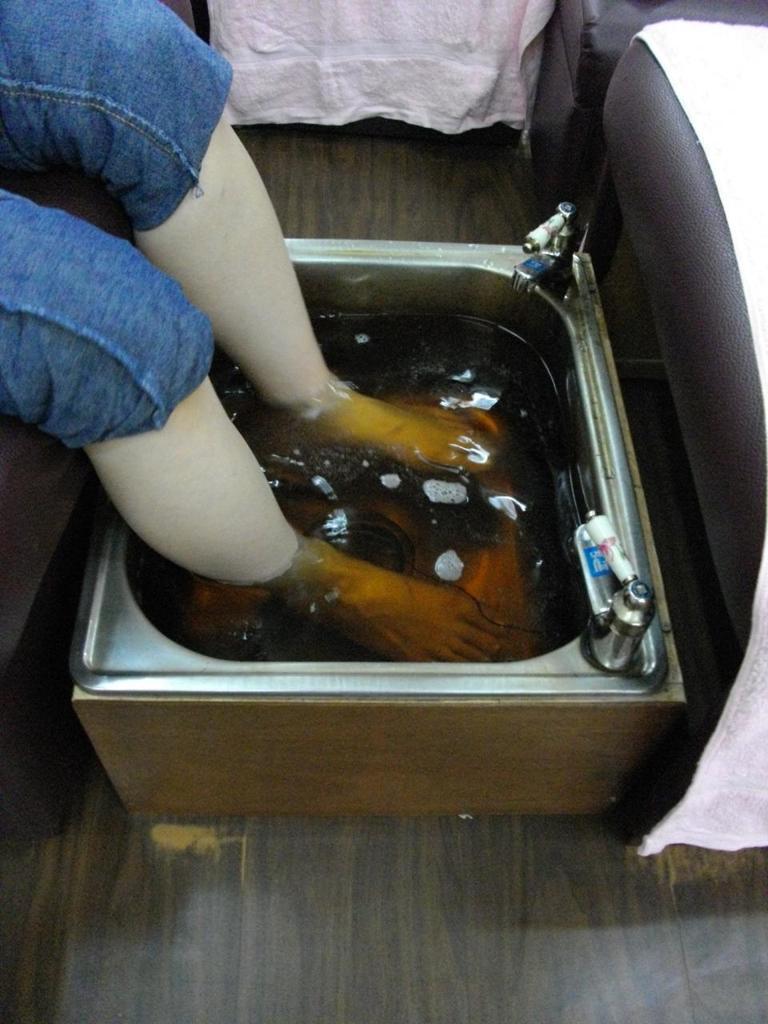How would you summarize this image in a sentence or two? In this image we can see persons legs in some liquid. At the bottom of the image there is wooden flooring. To the right side of the image there is a chair with a cloth on it. 